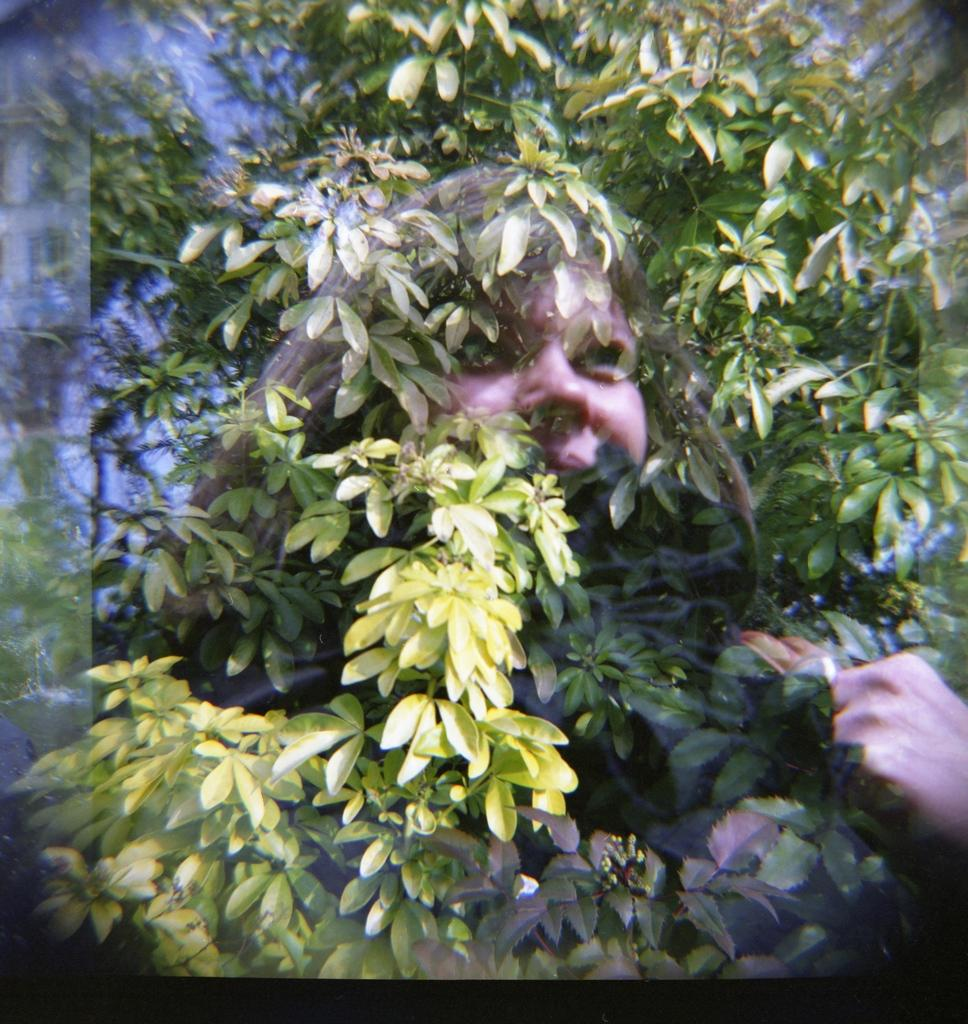What can be observed about the image's appearance? The image appears to be edited. Who or what is the main subject in the image? There is a woman's face in the image. What type of plant is visible in the image? There is a tree with branches and leaves in the image. What type of operation is being performed on the woman's face in the image? There is no indication of any operation being performed on the woman's face in the image. Can you hear the voice of the woman in the image? The image is a still image and does not contain any audio, so it is not possible to hear the woman's voice. 